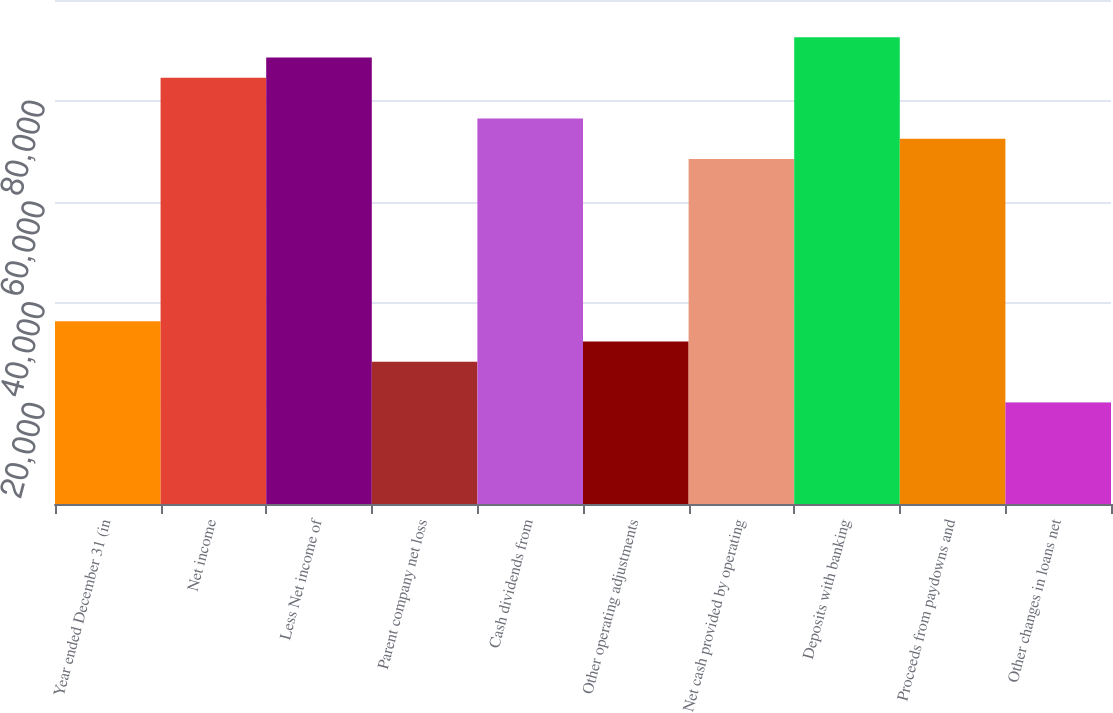<chart> <loc_0><loc_0><loc_500><loc_500><bar_chart><fcel>Year ended December 31 (in<fcel>Net income<fcel>Less Net income of<fcel>Parent company net loss<fcel>Cash dividends from<fcel>Other operating adjustments<fcel>Net cash provided by operating<fcel>Deposits with banking<fcel>Proceeds from paydowns and<fcel>Other changes in loans net<nl><fcel>36258.8<fcel>84561.2<fcel>88586.4<fcel>28208.4<fcel>76510.8<fcel>32233.6<fcel>68460.4<fcel>92611.6<fcel>72485.6<fcel>20158<nl></chart> 